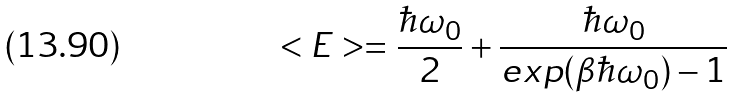Convert formula to latex. <formula><loc_0><loc_0><loc_500><loc_500>< E > = \frac { \hbar { \omega } _ { 0 } } { 2 } + \frac { \hbar { \omega } _ { 0 } } { e x p ( \beta \hbar { \omega } _ { 0 } ) - 1 }</formula> 